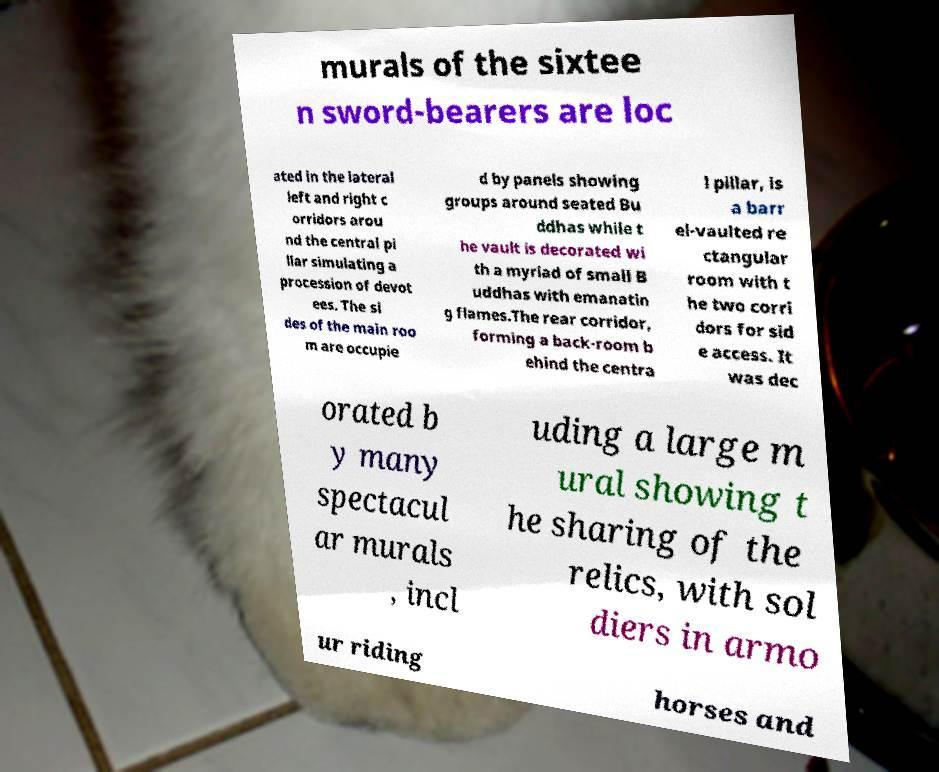Could you extract and type out the text from this image? murals of the sixtee n sword-bearers are loc ated in the lateral left and right c orridors arou nd the central pi llar simulating a procession of devot ees. The si des of the main roo m are occupie d by panels showing groups around seated Bu ddhas while t he vault is decorated wi th a myriad of small B uddhas with emanatin g flames.The rear corridor, forming a back-room b ehind the centra l pillar, is a barr el-vaulted re ctangular room with t he two corri dors for sid e access. It was dec orated b y many spectacul ar murals , incl uding a large m ural showing t he sharing of the relics, with sol diers in armo ur riding horses and 